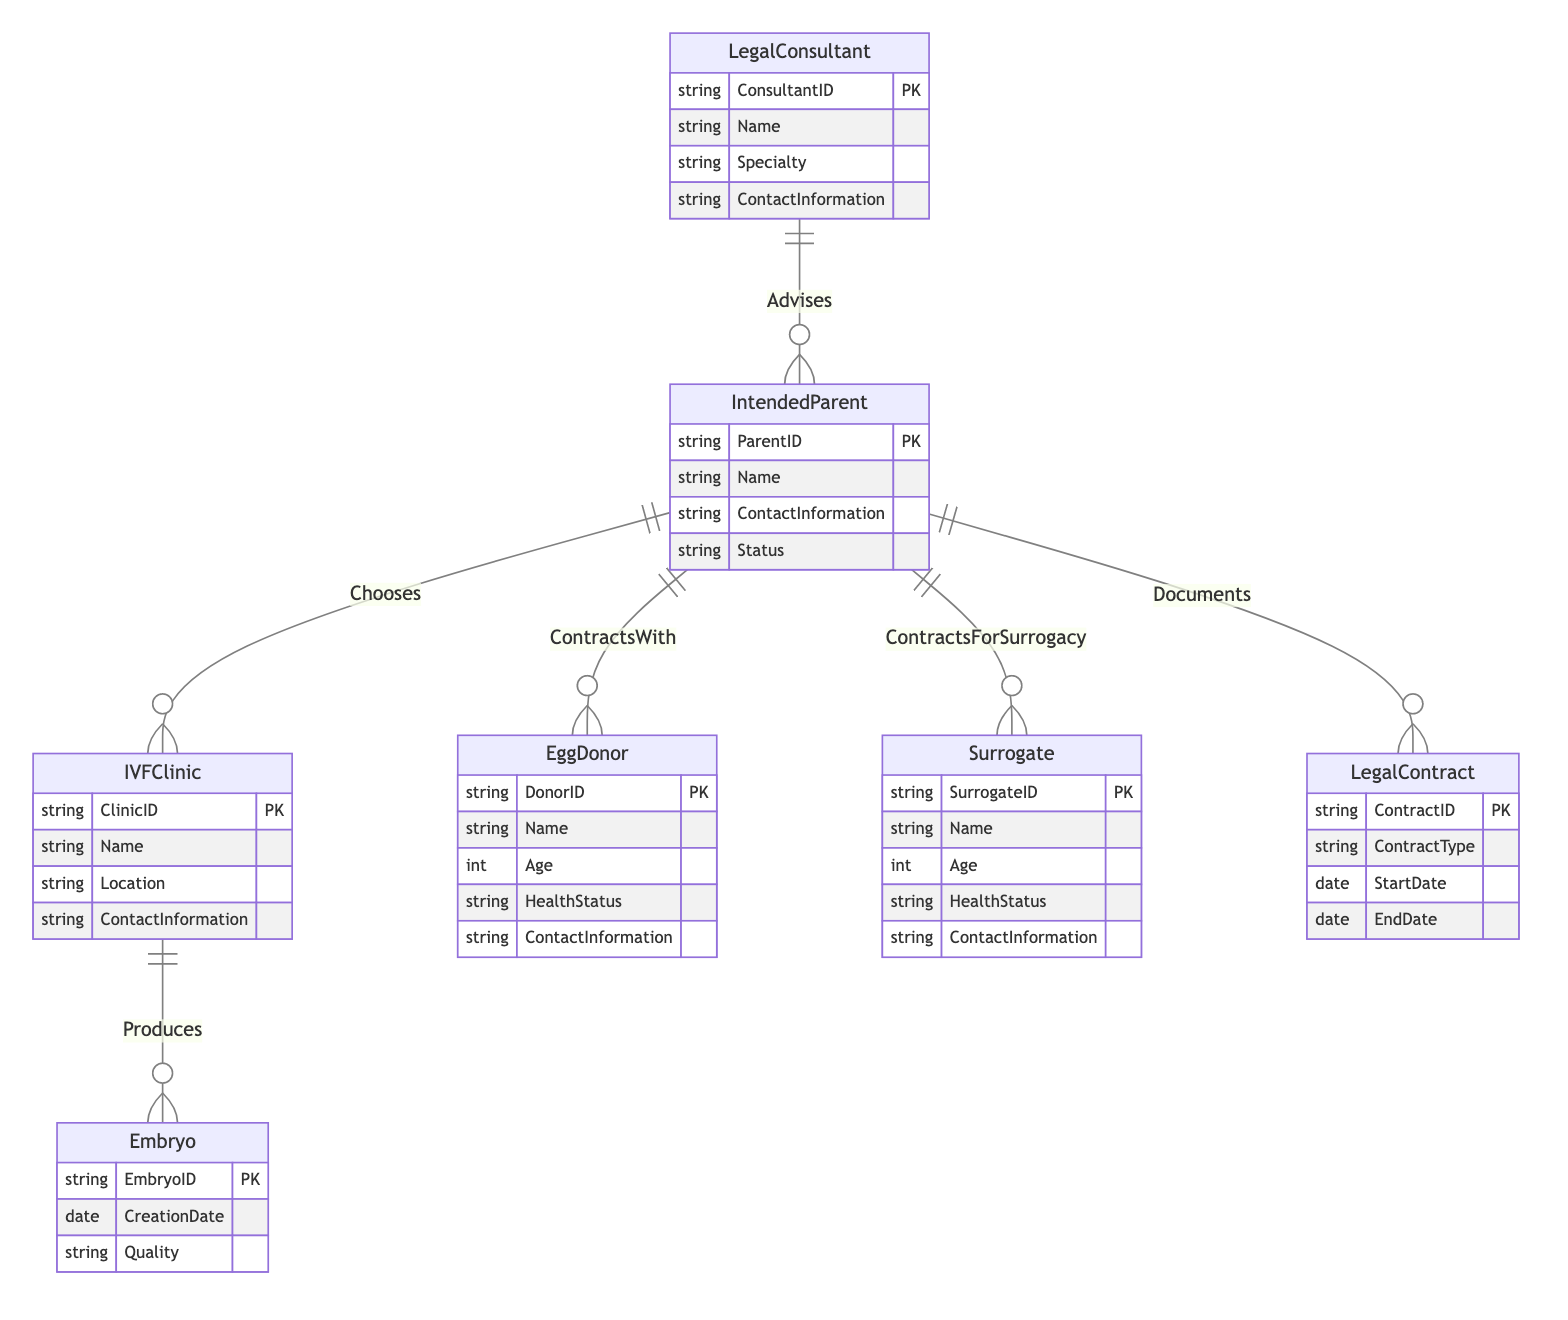What are the entities involved in the diagram? The entities listed in the diagram include Intended Parent, IVFClinic, Egg Donor, Surrogate, Legal Contract, Legal Consultant, and Embryo.
Answer: Intended Parent, IVFClinic, Egg Donor, Surrogate, Legal Contract, Legal Consultant, Embryo How many relationships are shown in the diagram? The diagram features six distinct relationships: Chooses, ContractsWith, ContractsForSurrogacy, Advises, Documents, and Produces, totaling six relationships.
Answer: 6 What entity is related to the IVFClinic through the Chooses relationship? The relationship Chooses links the Intended Parent to the IVFClinic, indicating that Intended Parent is the party that chooses the clinic.
Answer: Intended Parent What contract types are associated with the Intended Parent and Egg Donor? The relationship ContractsWith indicates a contractual relationship between the Intended Parent and Egg Donor, specifying StartDate, EndDate, and ContractType for this pairing.
Answer: ContractType Which entity produces Embryos? The IVFClinic entity is responsible for the production of Embryos as indicated by the relationship Produces in the diagram.
Answer: IVFClinic How does the Intended Parent interact with the Legal Consultant? The Intended Parent interacts with the Legal Consultant through the Advises relationship, which shows that the Consultant provides advice to the Intended Parent.
Answer: Advises What role does the LegalContract play in the diagram? The LegalContract entity documents the agreements involving the Intended Parent, and is related to them through the Documents relationship, reflecting the legal documentation aspect of the process.
Answer: Documents Which entities are involved in the ContractsForSurrogacy relationship? The ContractsForSurrogacy relationship exists between the Intended Parent and Surrogate, indicating a legal contractual relationship for surrogacy arrangements.
Answer: Intended Parent, Surrogate What information is included in the attributes of the Egg Donor entity? The attributes for the Egg Donor include DonorID, Name, Age, HealthStatus, and ContactInformation, which provides essential information about the donor.
Answer: DonorID, Name, Age, HealthStatus, ContactInformation 